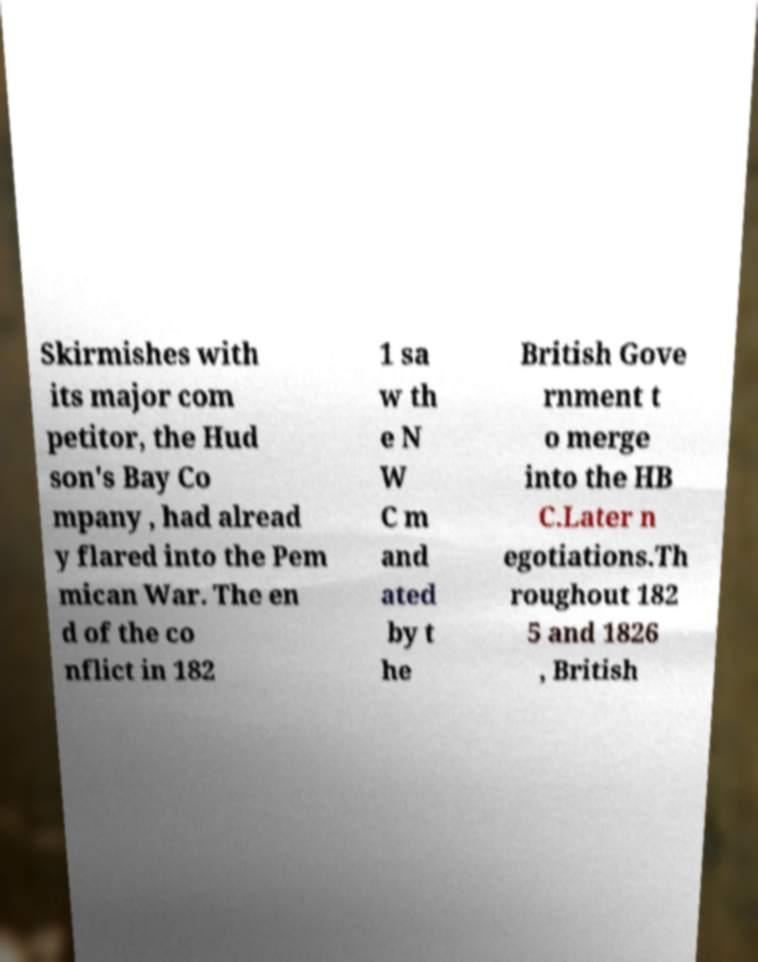Can you accurately transcribe the text from the provided image for me? Skirmishes with its major com petitor, the Hud son's Bay Co mpany , had alread y flared into the Pem mican War. The en d of the co nflict in 182 1 sa w th e N W C m and ated by t he British Gove rnment t o merge into the HB C.Later n egotiations.Th roughout 182 5 and 1826 , British 